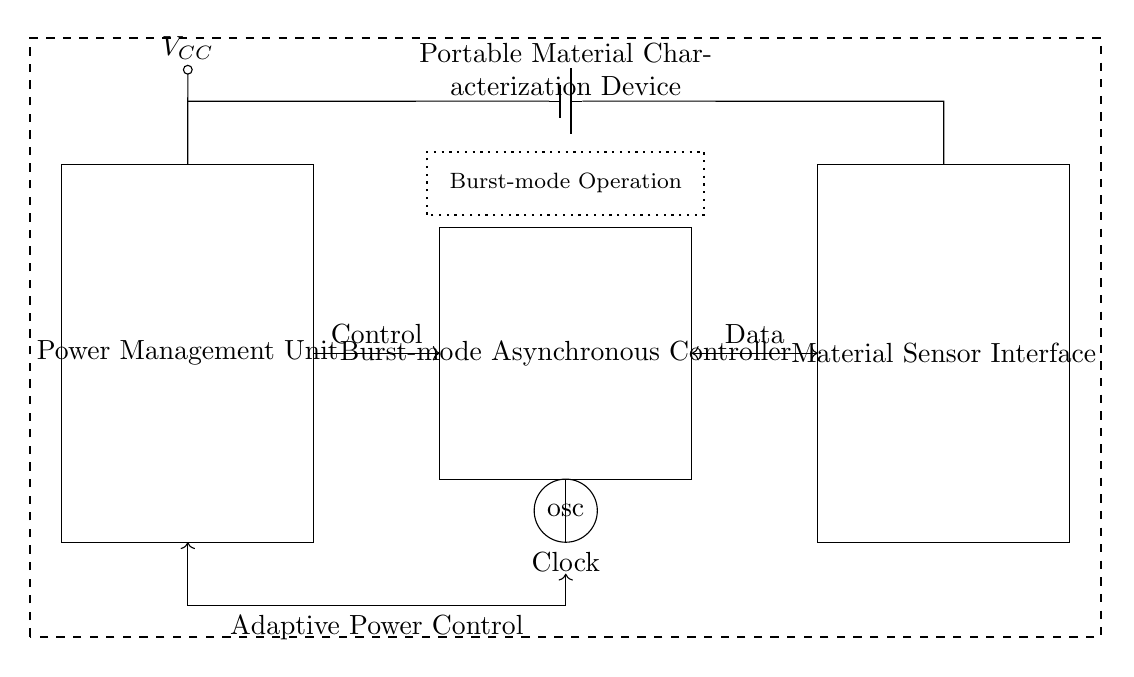What is the main purpose of this circuit? The main purpose of this circuit is to manage power adaptively in a portable material characterization device through a burst-mode asynchronous controller.
Answer: Power management What component provides the control signal in the circuit? The control signal is provided by the burst-mode asynchronous controller, which interfaces with the power management unit to adjust power based on system needs.
Answer: Burst-mode Asynchronous Controller What does the dotted rectangle represent in the diagram? The dotted rectangle indicates the area where burst-mode operation occurs, highlighting its significance within the asynchronous controller.
Answer: Burst-mode Operation How many separate components are in the power management section? The power management section consists of one main component, which is the power management unit.
Answer: One What type of operation does the clock signal indicate? The clock signal indicates the timing needed for synchronous communication within the circuit, which is essential for coordinating operations between the controller and sensor interface.
Answer: Burst-mode What is the relationship between the power management unit and the asynchronous controller regarding data transfer? The power management unit sends control signals to the asynchronous controller and receives data back in return, establishing a bi-directional communication link essential for adaptive power management.
Answer: Control and Data What role does the sensor interface play in this circuit? The sensor interface collects data from material characterization and routes it to the asynchronous controller for processing and adaptive power control.
Answer: Data acquisition 